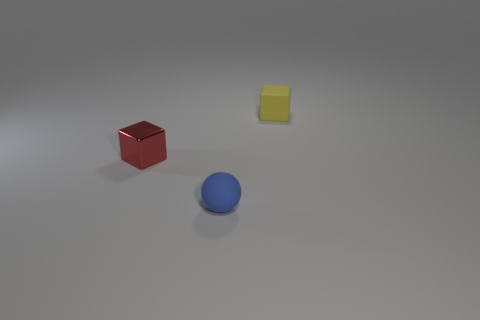How many objects are cyan metallic cylinders or tiny cubes left of the blue object?
Keep it short and to the point. 1. Are there an equal number of tiny blue balls that are behind the matte block and tiny red metallic cubes behind the blue thing?
Provide a succinct answer. No. There is a blue rubber sphere that is in front of the yellow object; is there a rubber object right of it?
Offer a very short reply. Yes. What shape is the blue thing that is the same material as the small yellow block?
Make the answer very short. Sphere. Is there anything else of the same color as the tiny rubber ball?
Your answer should be very brief. No. What is the material of the red cube that is behind the tiny ball that is in front of the shiny block?
Offer a very short reply. Metal. Is there a small red shiny thing that has the same shape as the tiny yellow matte thing?
Offer a very short reply. Yes. What number of other objects are the same shape as the yellow thing?
Offer a very short reply. 1. What is the shape of the tiny object that is both behind the tiny rubber ball and right of the small red shiny cube?
Your response must be concise. Cube. What is the size of the object that is behind the small shiny cube?
Provide a short and direct response. Small. 